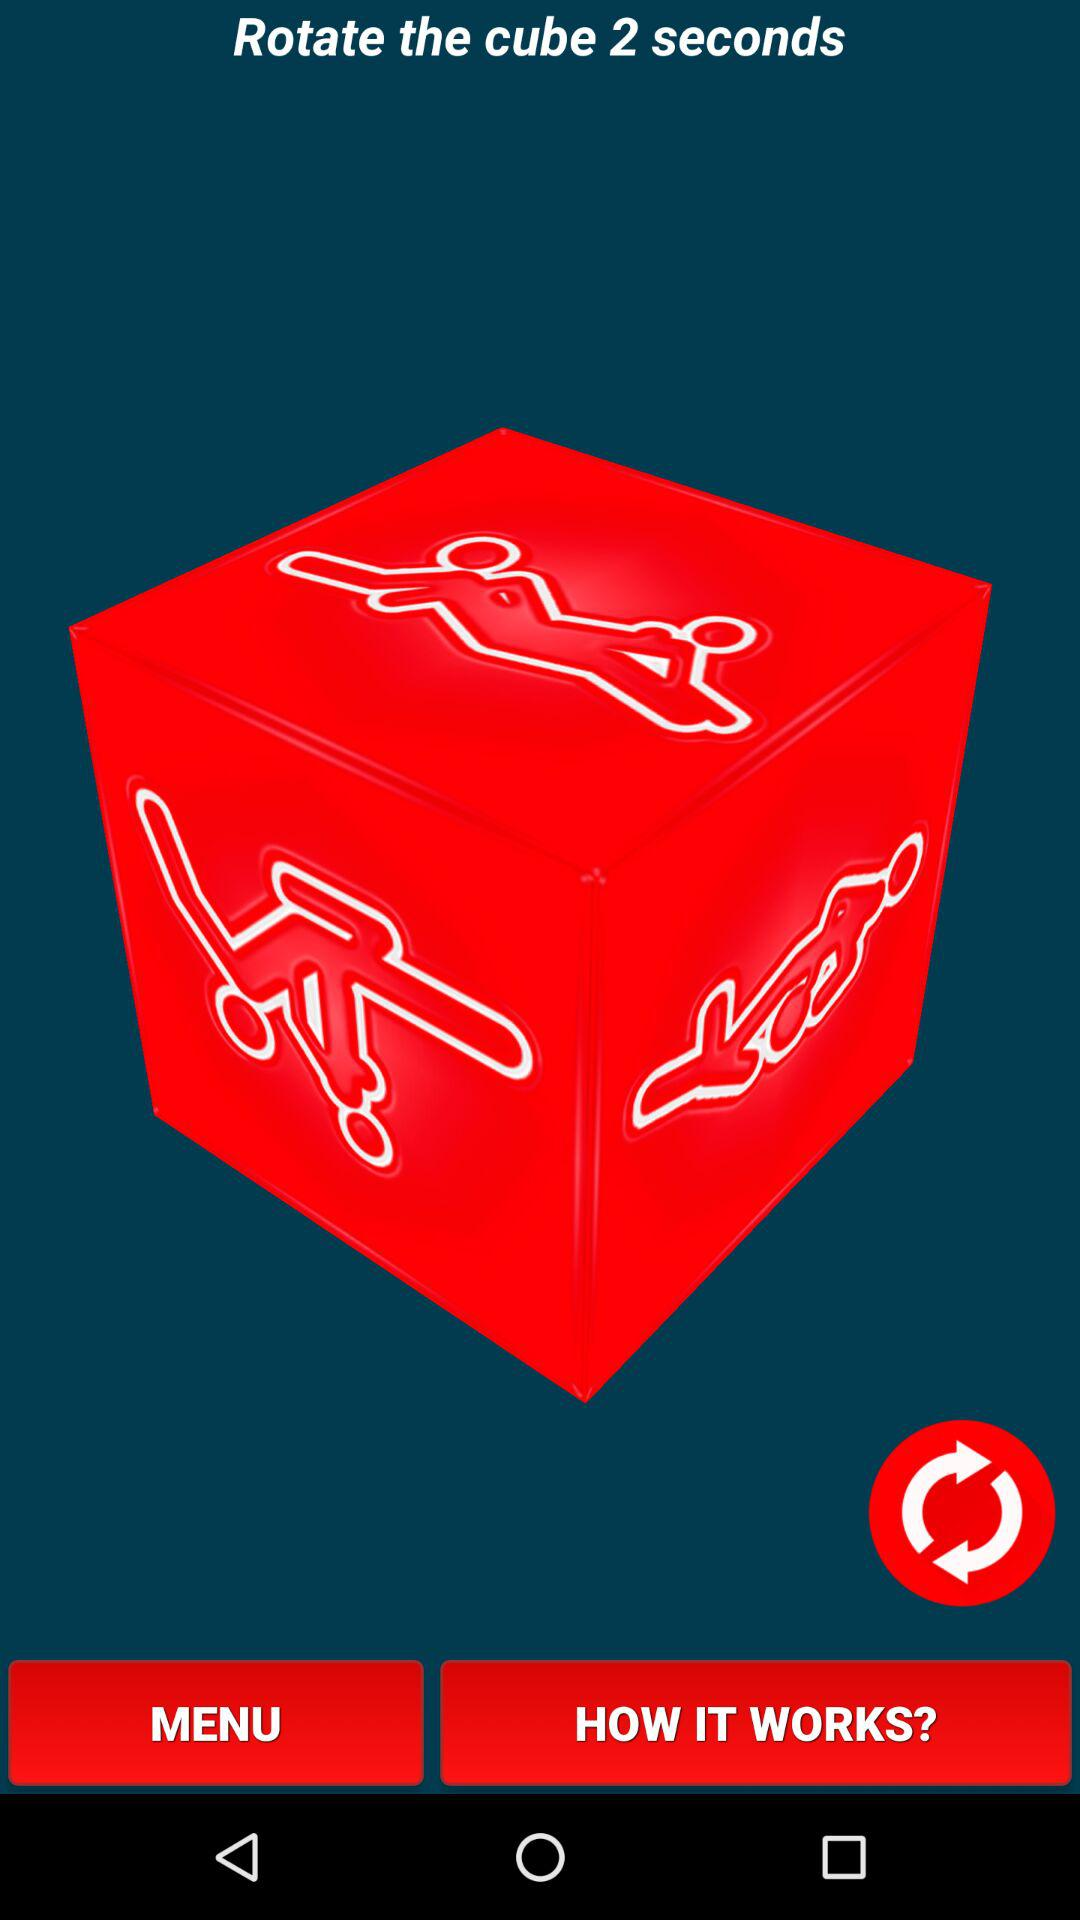How many seconds does the cube take to rotate? The cube takes 2 seconds to rotate. 